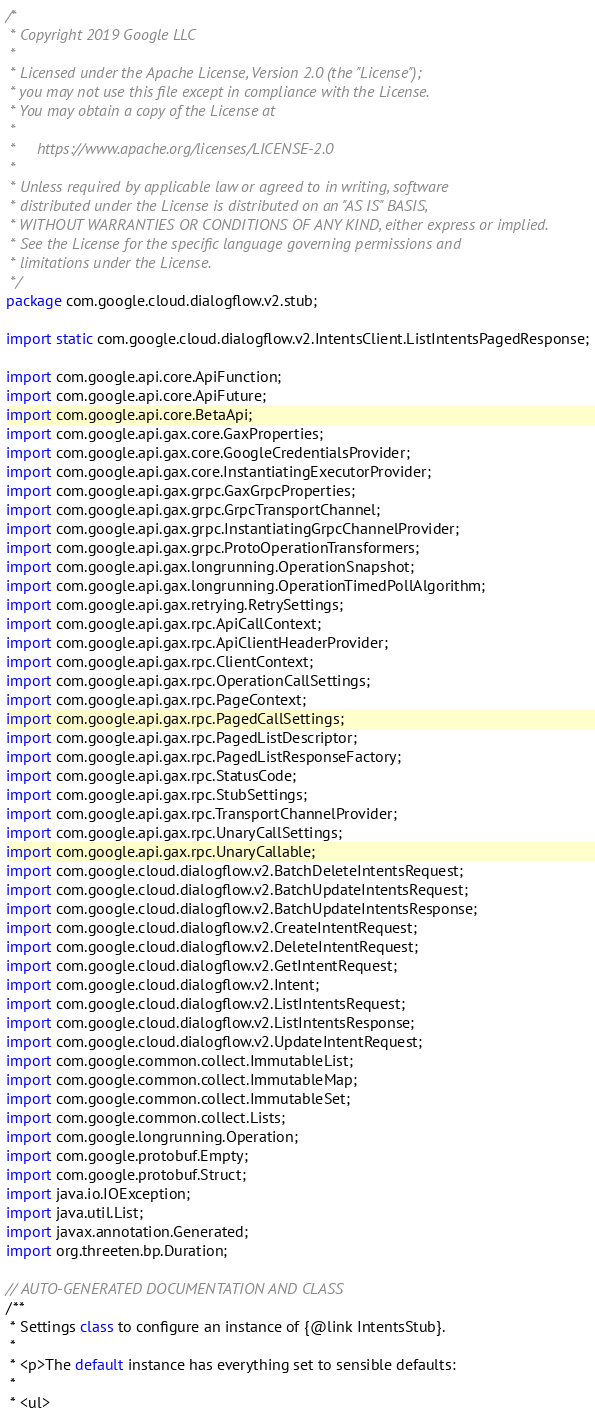<code> <loc_0><loc_0><loc_500><loc_500><_Java_>/*
 * Copyright 2019 Google LLC
 *
 * Licensed under the Apache License, Version 2.0 (the "License");
 * you may not use this file except in compliance with the License.
 * You may obtain a copy of the License at
 *
 *     https://www.apache.org/licenses/LICENSE-2.0
 *
 * Unless required by applicable law or agreed to in writing, software
 * distributed under the License is distributed on an "AS IS" BASIS,
 * WITHOUT WARRANTIES OR CONDITIONS OF ANY KIND, either express or implied.
 * See the License for the specific language governing permissions and
 * limitations under the License.
 */
package com.google.cloud.dialogflow.v2.stub;

import static com.google.cloud.dialogflow.v2.IntentsClient.ListIntentsPagedResponse;

import com.google.api.core.ApiFunction;
import com.google.api.core.ApiFuture;
import com.google.api.core.BetaApi;
import com.google.api.gax.core.GaxProperties;
import com.google.api.gax.core.GoogleCredentialsProvider;
import com.google.api.gax.core.InstantiatingExecutorProvider;
import com.google.api.gax.grpc.GaxGrpcProperties;
import com.google.api.gax.grpc.GrpcTransportChannel;
import com.google.api.gax.grpc.InstantiatingGrpcChannelProvider;
import com.google.api.gax.grpc.ProtoOperationTransformers;
import com.google.api.gax.longrunning.OperationSnapshot;
import com.google.api.gax.longrunning.OperationTimedPollAlgorithm;
import com.google.api.gax.retrying.RetrySettings;
import com.google.api.gax.rpc.ApiCallContext;
import com.google.api.gax.rpc.ApiClientHeaderProvider;
import com.google.api.gax.rpc.ClientContext;
import com.google.api.gax.rpc.OperationCallSettings;
import com.google.api.gax.rpc.PageContext;
import com.google.api.gax.rpc.PagedCallSettings;
import com.google.api.gax.rpc.PagedListDescriptor;
import com.google.api.gax.rpc.PagedListResponseFactory;
import com.google.api.gax.rpc.StatusCode;
import com.google.api.gax.rpc.StubSettings;
import com.google.api.gax.rpc.TransportChannelProvider;
import com.google.api.gax.rpc.UnaryCallSettings;
import com.google.api.gax.rpc.UnaryCallable;
import com.google.cloud.dialogflow.v2.BatchDeleteIntentsRequest;
import com.google.cloud.dialogflow.v2.BatchUpdateIntentsRequest;
import com.google.cloud.dialogflow.v2.BatchUpdateIntentsResponse;
import com.google.cloud.dialogflow.v2.CreateIntentRequest;
import com.google.cloud.dialogflow.v2.DeleteIntentRequest;
import com.google.cloud.dialogflow.v2.GetIntentRequest;
import com.google.cloud.dialogflow.v2.Intent;
import com.google.cloud.dialogflow.v2.ListIntentsRequest;
import com.google.cloud.dialogflow.v2.ListIntentsResponse;
import com.google.cloud.dialogflow.v2.UpdateIntentRequest;
import com.google.common.collect.ImmutableList;
import com.google.common.collect.ImmutableMap;
import com.google.common.collect.ImmutableSet;
import com.google.common.collect.Lists;
import com.google.longrunning.Operation;
import com.google.protobuf.Empty;
import com.google.protobuf.Struct;
import java.io.IOException;
import java.util.List;
import javax.annotation.Generated;
import org.threeten.bp.Duration;

// AUTO-GENERATED DOCUMENTATION AND CLASS
/**
 * Settings class to configure an instance of {@link IntentsStub}.
 *
 * <p>The default instance has everything set to sensible defaults:
 *
 * <ul></code> 